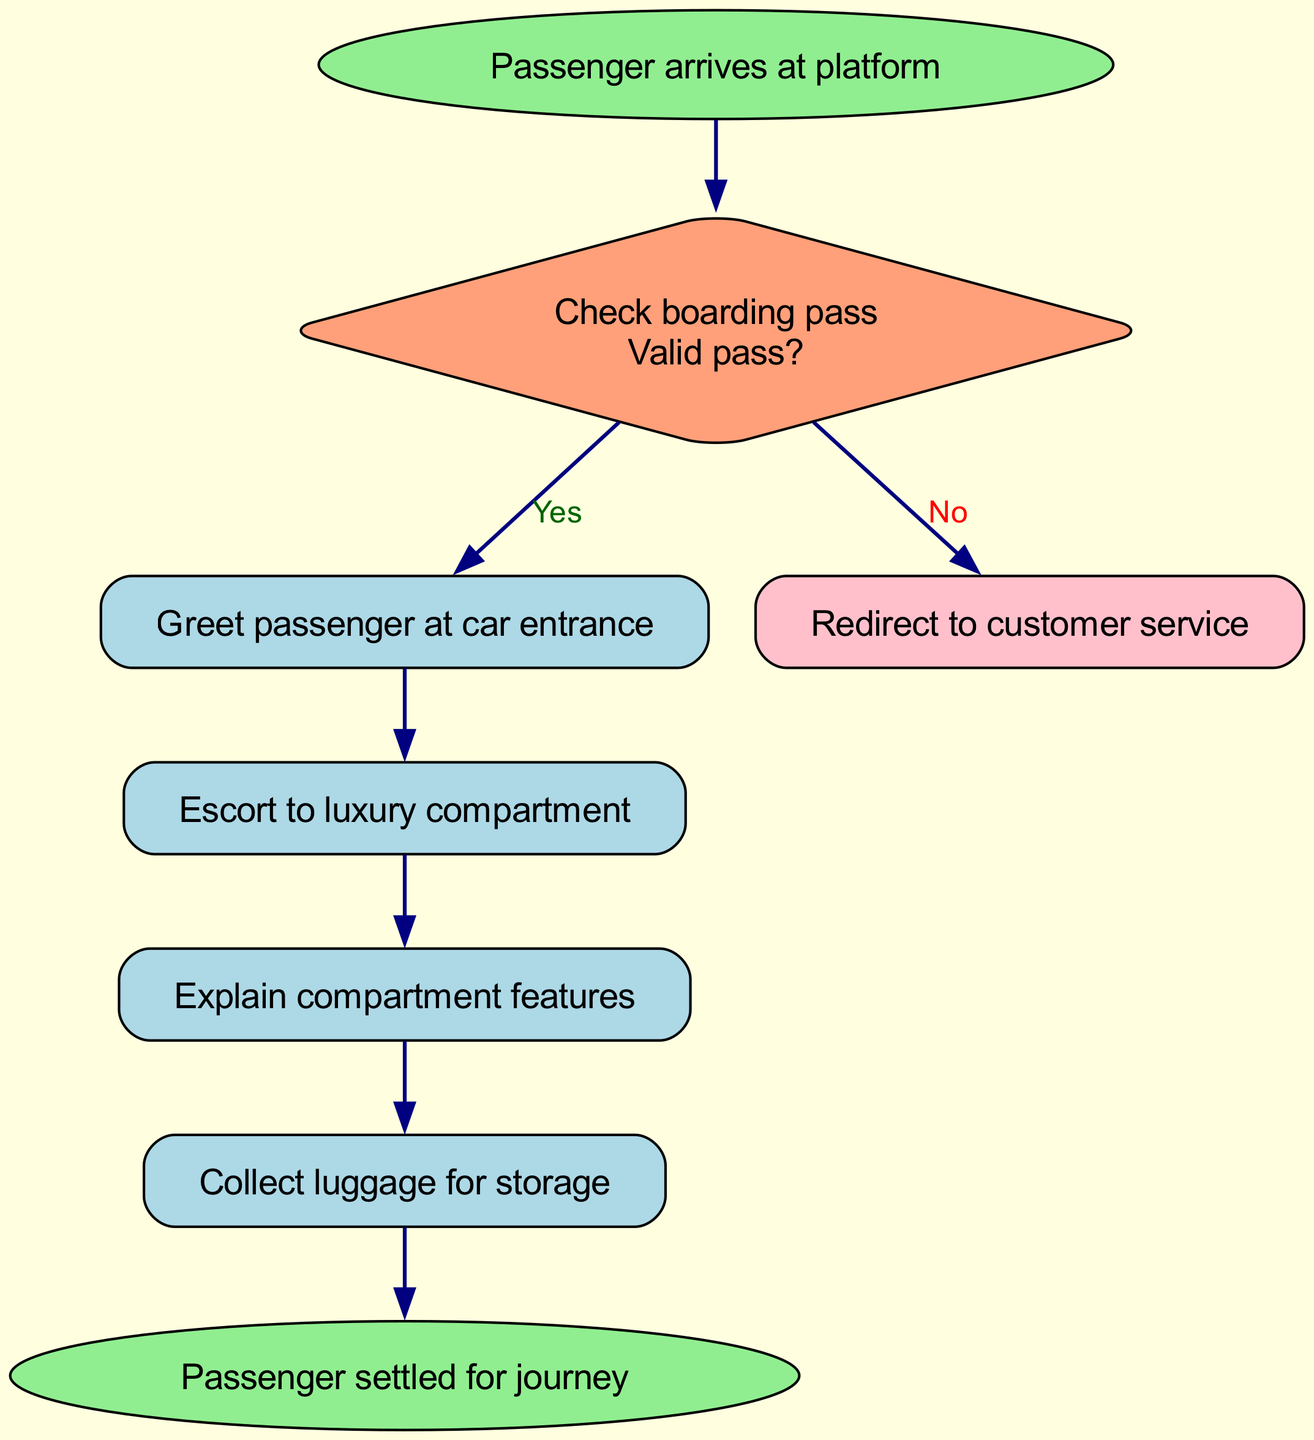What is the first action in the boarding process? The first action is stated at the starting node, which is "Passenger arrives at platform."
Answer: Passenger arrives at platform How many steps are there in the boarding process? There are six steps listed in the process, counting the start and end nodes as relevant points.
Answer: 6 What happens if the boarding pass is not valid? If the boarding pass is not valid, the flow directs to "Redirect to customer service." This is outlined in the decision point connected to the boarding pass check.
Answer: Redirect to customer service What is the last action before the journey begins? The last action before the journey starts is "Passenger settled for journey," which is indicated by the end node in the diagram.
Answer: Passenger settled for journey What does the train staff offer after escorting the passenger? After escorting the passenger to the luxury compartment, the next action is to "Offer welcome champagne." This follows directly after the escorting step in the process.
Answer: Offer welcome champagne How many decisions are shown in the diagram? There is one decision point in the diagram regarding the validity of the boarding pass, indicating a branching to either proceed or redirect.
Answer: 1 What are the personalized amenities provided after explaining compartment features? After explaining compartment features, the next step is "Provide personalized amenities," indicating a service tailored to the passenger's preferences.
Answer: Provide personalized amenities What is the relationship between "Check boarding pass" and "Proceed to car entrance"? The relationship is conditional; if the boarding pass is valid, the flow proceeds to "Proceed to car entrance," which follows the decision regarding the validity of the pass.
Answer: Validity leads to proceeding What action follows "Collect luggage for storage"? The action that follows "Collect luggage for storage" is "Ensure passenger comfort," indicating a focus on the passenger's well-being post luggage collection.
Answer: Ensure passenger comfort 